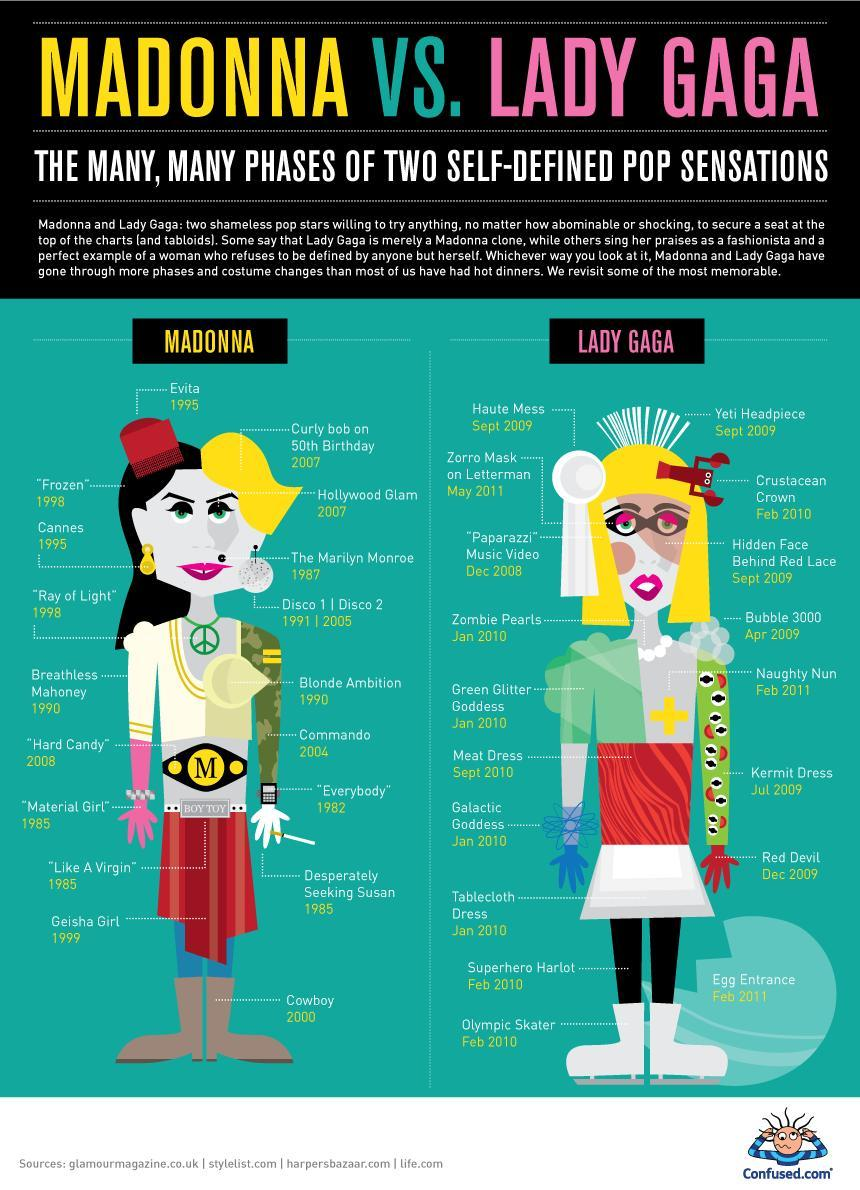What is the year associated with "Zombie Pearls" of Lady Gaga?
Answer the question with a short phrase. 2010 In which year did Lady Gaga wore Zorro Mask on Letterman? May 2011 Which is the letter written on the belt of Madonna? M In which year Madonnas Disco 1 was released? 1991 